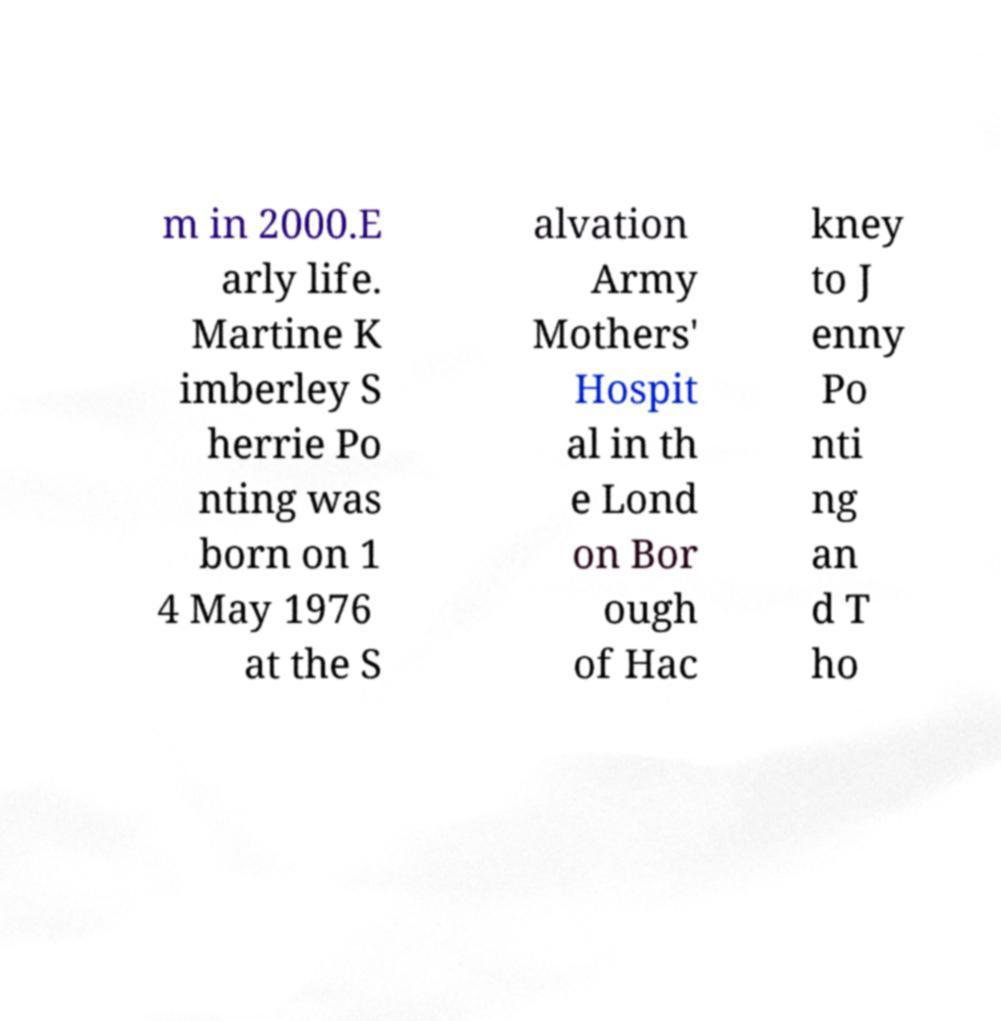Can you read and provide the text displayed in the image?This photo seems to have some interesting text. Can you extract and type it out for me? m in 2000.E arly life. Martine K imberley S herrie Po nting was born on 1 4 May 1976 at the S alvation Army Mothers' Hospit al in th e Lond on Bor ough of Hac kney to J enny Po nti ng an d T ho 